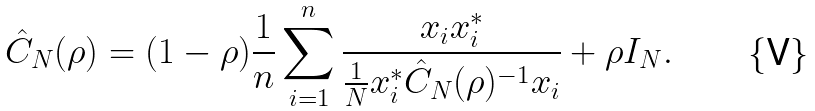<formula> <loc_0><loc_0><loc_500><loc_500>\hat { C } _ { N } ( \rho ) & = ( 1 - \rho ) \frac { 1 } { n } \sum _ { i = 1 } ^ { n } \frac { x _ { i } x _ { i } ^ { * } } { \frac { 1 } { N } x _ { i } ^ { * } \hat { C } _ { N } ( \rho ) ^ { - 1 } x _ { i } } + \rho I _ { N } .</formula> 